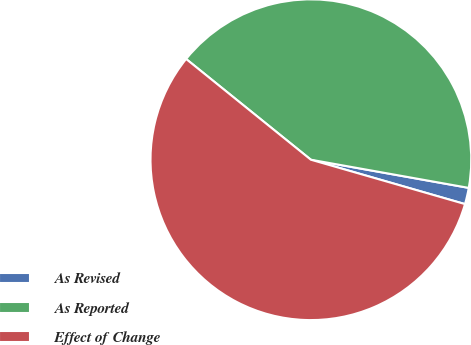<chart> <loc_0><loc_0><loc_500><loc_500><pie_chart><fcel>As Revised<fcel>As Reported<fcel>Effect of Change<nl><fcel>1.65%<fcel>42.0%<fcel>56.35%<nl></chart> 